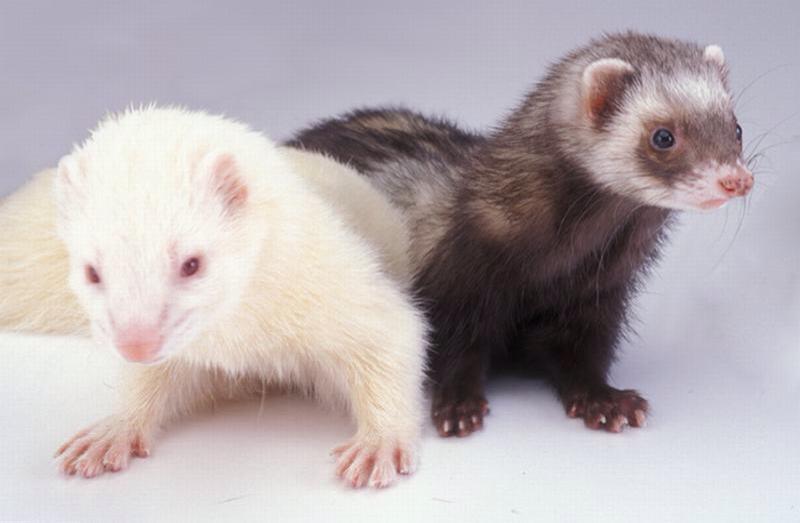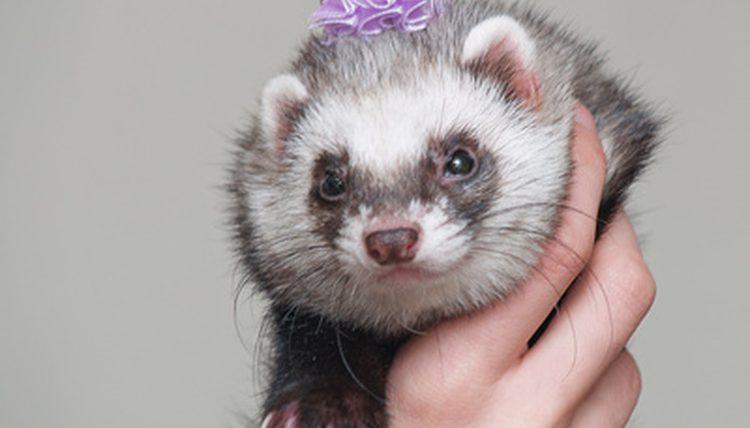The first image is the image on the left, the second image is the image on the right. Examine the images to the left and right. Is the description "There are exactly two ferrets in the image on the left." accurate? Answer yes or no. Yes. 